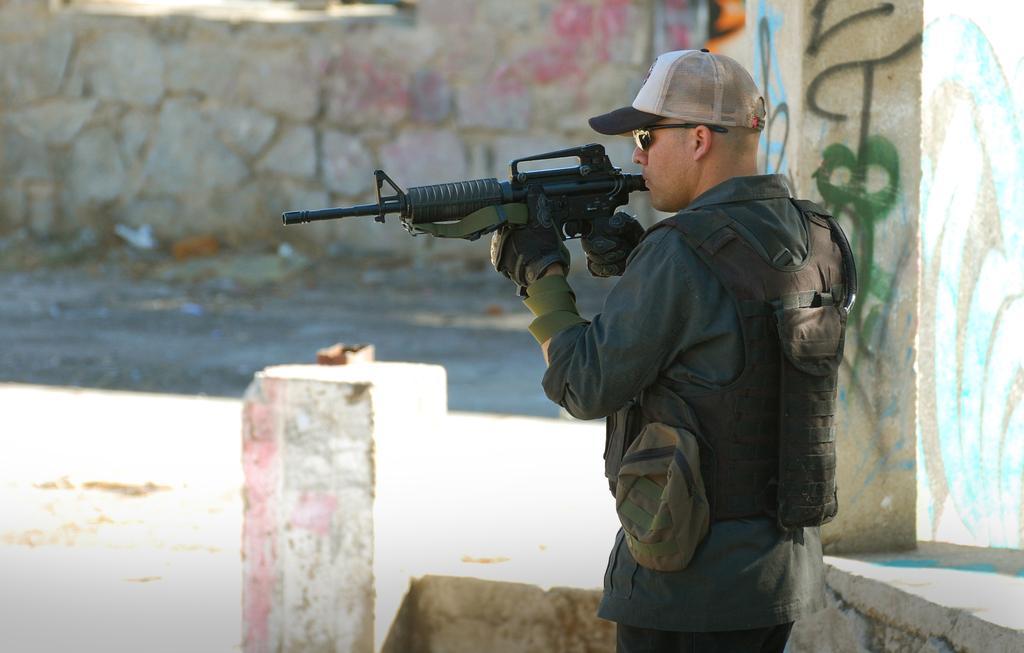How would you summarize this image in a sentence or two? In this image in the front there is a man standing and holding a gun. In the center there is a pillar. In the background there is a wall. 